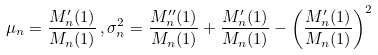<formula> <loc_0><loc_0><loc_500><loc_500>\mu _ { n } = \frac { M _ { n } ^ { \prime } ( 1 ) } { M _ { n } ( 1 ) } \, , \sigma _ { n } ^ { 2 } = \frac { M _ { n } ^ { \prime \prime } ( 1 ) } { M _ { n } ( 1 ) } + \frac { M _ { n } ^ { \prime } ( 1 ) } { M _ { n } ( 1 ) } - \left ( \frac { M _ { n } ^ { \prime } ( 1 ) } { M _ { n } ( 1 ) } \right ) ^ { 2 }</formula> 